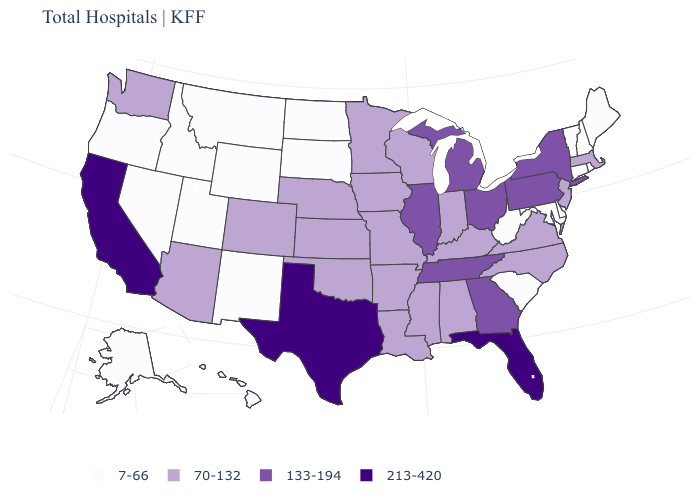What is the value of Pennsylvania?
Short answer required. 133-194. Name the states that have a value in the range 133-194?
Answer briefly. Georgia, Illinois, Michigan, New York, Ohio, Pennsylvania, Tennessee. What is the value of Rhode Island?
Concise answer only. 7-66. Does Missouri have the lowest value in the MidWest?
Write a very short answer. No. Does West Virginia have the lowest value in the USA?
Give a very brief answer. Yes. Among the states that border New York , does Massachusetts have the lowest value?
Write a very short answer. No. What is the value of Georgia?
Concise answer only. 133-194. Does Idaho have the lowest value in the USA?
Give a very brief answer. Yes. Name the states that have a value in the range 213-420?
Concise answer only. California, Florida, Texas. Which states have the lowest value in the USA?
Quick response, please. Alaska, Connecticut, Delaware, Hawaii, Idaho, Maine, Maryland, Montana, Nevada, New Hampshire, New Mexico, North Dakota, Oregon, Rhode Island, South Carolina, South Dakota, Utah, Vermont, West Virginia, Wyoming. Does Pennsylvania have the lowest value in the Northeast?
Be succinct. No. What is the value of Connecticut?
Give a very brief answer. 7-66. What is the highest value in the MidWest ?
Answer briefly. 133-194. What is the value of Massachusetts?
Keep it brief. 70-132. Does Iowa have the highest value in the USA?
Answer briefly. No. 